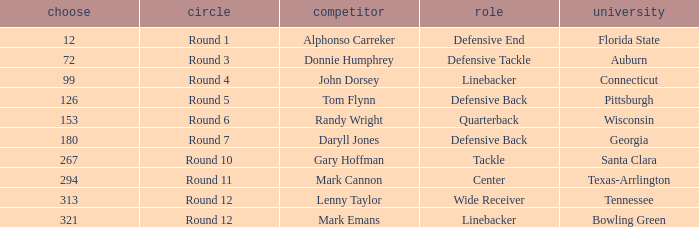Would you mind parsing the complete table? {'header': ['choose', 'circle', 'competitor', 'role', 'university'], 'rows': [['12', 'Round 1', 'Alphonso Carreker', 'Defensive End', 'Florida State'], ['72', 'Round 3', 'Donnie Humphrey', 'Defensive Tackle', 'Auburn'], ['99', 'Round 4', 'John Dorsey', 'Linebacker', 'Connecticut'], ['126', 'Round 5', 'Tom Flynn', 'Defensive Back', 'Pittsburgh'], ['153', 'Round 6', 'Randy Wright', 'Quarterback', 'Wisconsin'], ['180', 'Round 7', 'Daryll Jones', 'Defensive Back', 'Georgia'], ['267', 'Round 10', 'Gary Hoffman', 'Tackle', 'Santa Clara'], ['294', 'Round 11', 'Mark Cannon', 'Center', 'Texas-Arrlington'], ['313', 'Round 12', 'Lenny Taylor', 'Wide Receiver', 'Tennessee'], ['321', 'Round 12', 'Mark Emans', 'Linebacker', 'Bowling Green']]} What is Mark Cannon's College? Texas-Arrlington. 